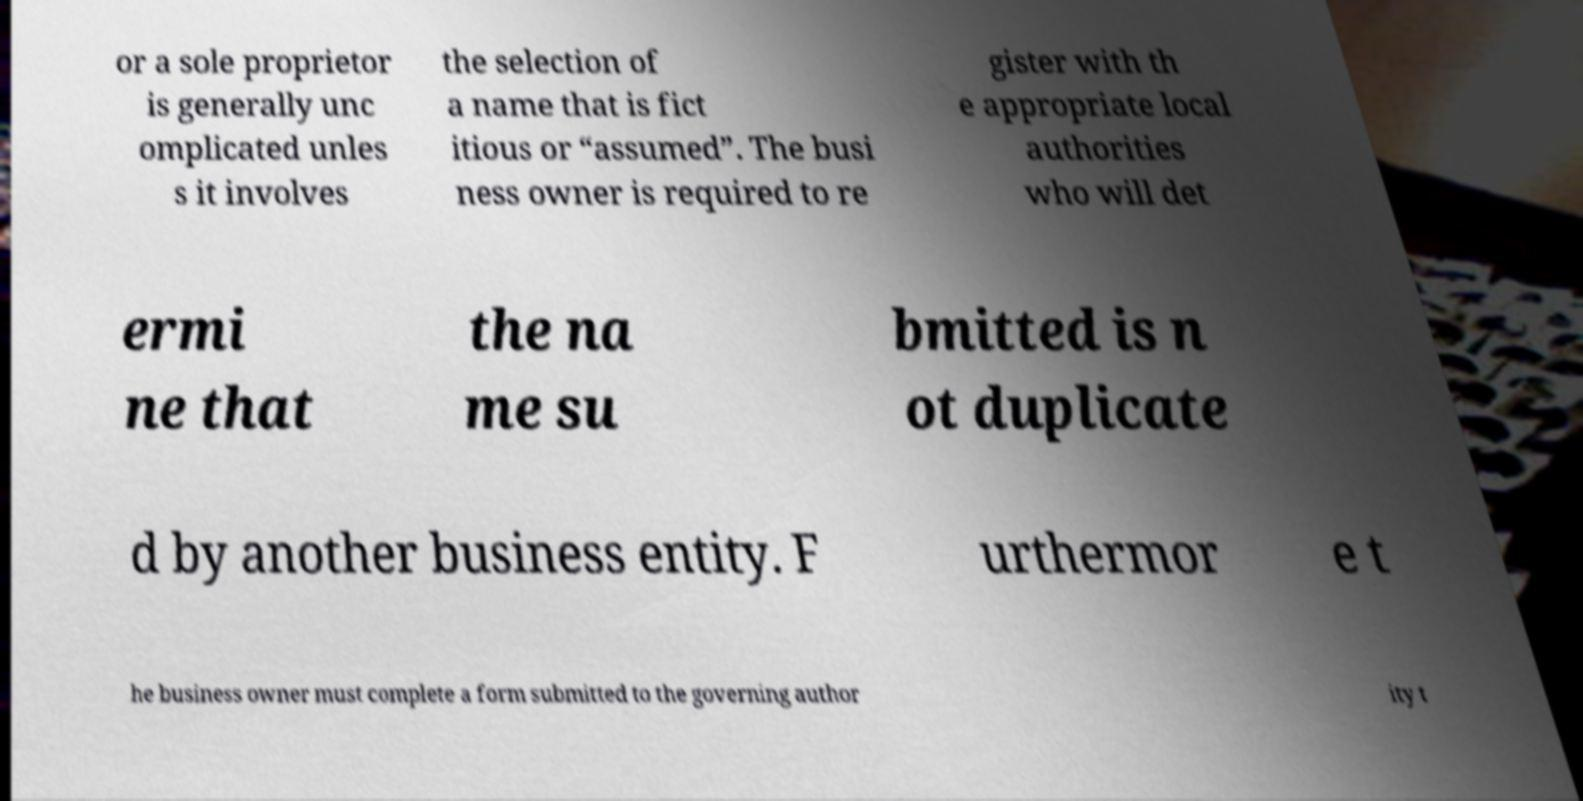Please read and relay the text visible in this image. What does it say? or a sole proprietor is generally unc omplicated unles s it involves the selection of a name that is fict itious or “assumed”. The busi ness owner is required to re gister with th e appropriate local authorities who will det ermi ne that the na me su bmitted is n ot duplicate d by another business entity. F urthermor e t he business owner must complete a form submitted to the governing author ity t 